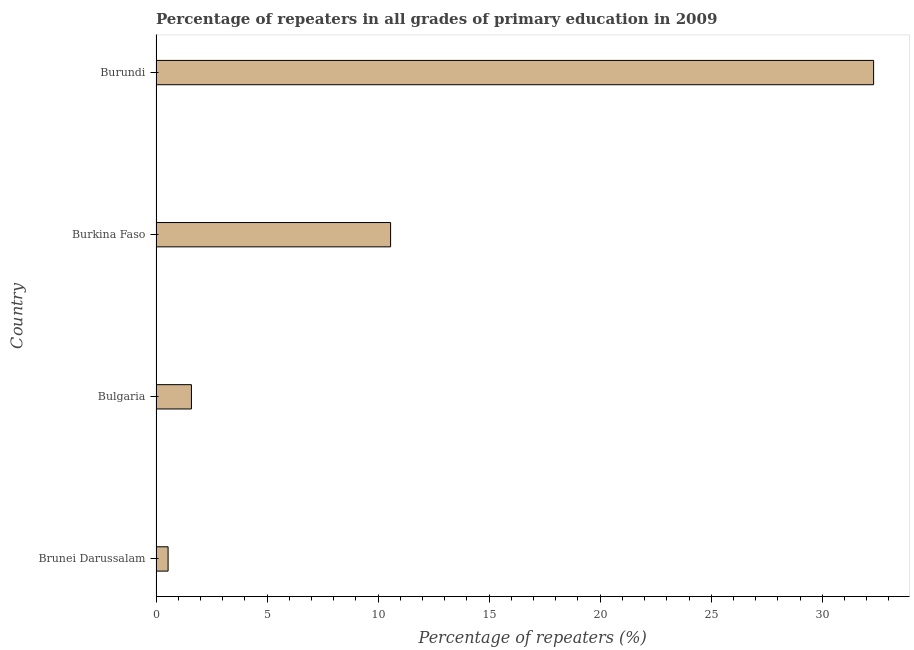Does the graph contain any zero values?
Keep it short and to the point. No. What is the title of the graph?
Your response must be concise. Percentage of repeaters in all grades of primary education in 2009. What is the label or title of the X-axis?
Keep it short and to the point. Percentage of repeaters (%). What is the label or title of the Y-axis?
Provide a short and direct response. Country. What is the percentage of repeaters in primary education in Burundi?
Your response must be concise. 32.31. Across all countries, what is the maximum percentage of repeaters in primary education?
Provide a succinct answer. 32.31. Across all countries, what is the minimum percentage of repeaters in primary education?
Your answer should be very brief. 0.54. In which country was the percentage of repeaters in primary education maximum?
Your answer should be compact. Burundi. In which country was the percentage of repeaters in primary education minimum?
Ensure brevity in your answer.  Brunei Darussalam. What is the sum of the percentage of repeaters in primary education?
Your response must be concise. 45.01. What is the difference between the percentage of repeaters in primary education in Burkina Faso and Burundi?
Give a very brief answer. -21.75. What is the average percentage of repeaters in primary education per country?
Make the answer very short. 11.25. What is the median percentage of repeaters in primary education?
Keep it short and to the point. 6.08. In how many countries, is the percentage of repeaters in primary education greater than 30 %?
Keep it short and to the point. 1. What is the ratio of the percentage of repeaters in primary education in Bulgaria to that in Burundi?
Offer a terse response. 0.05. Is the percentage of repeaters in primary education in Brunei Darussalam less than that in Burkina Faso?
Make the answer very short. Yes. What is the difference between the highest and the second highest percentage of repeaters in primary education?
Keep it short and to the point. 21.75. Is the sum of the percentage of repeaters in primary education in Brunei Darussalam and Burkina Faso greater than the maximum percentage of repeaters in primary education across all countries?
Keep it short and to the point. No. What is the difference between the highest and the lowest percentage of repeaters in primary education?
Offer a very short reply. 31.77. In how many countries, is the percentage of repeaters in primary education greater than the average percentage of repeaters in primary education taken over all countries?
Make the answer very short. 1. How many countries are there in the graph?
Offer a terse response. 4. What is the difference between two consecutive major ticks on the X-axis?
Your answer should be compact. 5. What is the Percentage of repeaters (%) in Brunei Darussalam?
Ensure brevity in your answer.  0.54. What is the Percentage of repeaters (%) of Bulgaria?
Make the answer very short. 1.59. What is the Percentage of repeaters (%) of Burkina Faso?
Offer a very short reply. 10.56. What is the Percentage of repeaters (%) in Burundi?
Provide a short and direct response. 32.31. What is the difference between the Percentage of repeaters (%) in Brunei Darussalam and Bulgaria?
Offer a terse response. -1.05. What is the difference between the Percentage of repeaters (%) in Brunei Darussalam and Burkina Faso?
Offer a very short reply. -10.02. What is the difference between the Percentage of repeaters (%) in Brunei Darussalam and Burundi?
Your response must be concise. -31.77. What is the difference between the Percentage of repeaters (%) in Bulgaria and Burkina Faso?
Your answer should be compact. -8.97. What is the difference between the Percentage of repeaters (%) in Bulgaria and Burundi?
Keep it short and to the point. -30.72. What is the difference between the Percentage of repeaters (%) in Burkina Faso and Burundi?
Your answer should be very brief. -21.75. What is the ratio of the Percentage of repeaters (%) in Brunei Darussalam to that in Bulgaria?
Give a very brief answer. 0.34. What is the ratio of the Percentage of repeaters (%) in Brunei Darussalam to that in Burkina Faso?
Provide a succinct answer. 0.05. What is the ratio of the Percentage of repeaters (%) in Brunei Darussalam to that in Burundi?
Ensure brevity in your answer.  0.02. What is the ratio of the Percentage of repeaters (%) in Bulgaria to that in Burkina Faso?
Give a very brief answer. 0.15. What is the ratio of the Percentage of repeaters (%) in Bulgaria to that in Burundi?
Keep it short and to the point. 0.05. What is the ratio of the Percentage of repeaters (%) in Burkina Faso to that in Burundi?
Offer a very short reply. 0.33. 